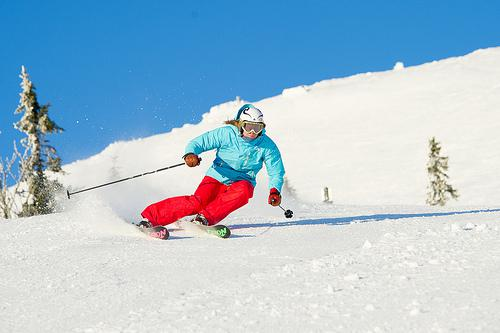Question: what is the color of the woman's jacket?
Choices:
A. Blue.
B. Green.
C. Red.
D. Purple.
Answer with the letter. Answer: A Question: where was the photo taken?
Choices:
A. By the steps.
B. By the shops.
C. Ski slope.
D. In the restaurant.
Answer with the letter. Answer: C Question: how many people are depicted?
Choices:
A. 1.
B. 5.
C. 3.
D. 7.
Answer with the letter. Answer: A Question: what is the woman doing?
Choices:
A. Skating.
B. Skiing.
C. Falling.
D. Walking.
Answer with the letter. Answer: B 